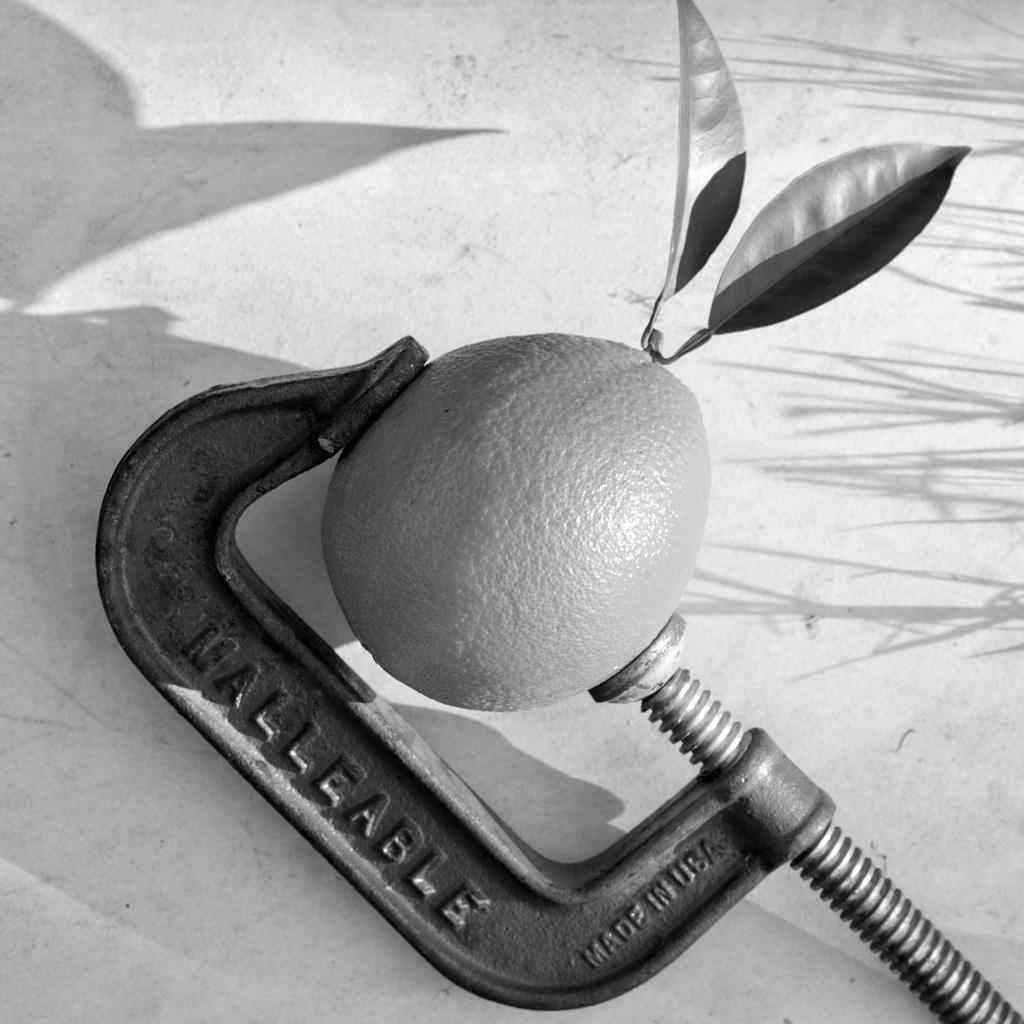<image>
Offer a succinct explanation of the picture presented. a lemon squeezer that says 'nalleable' on it 